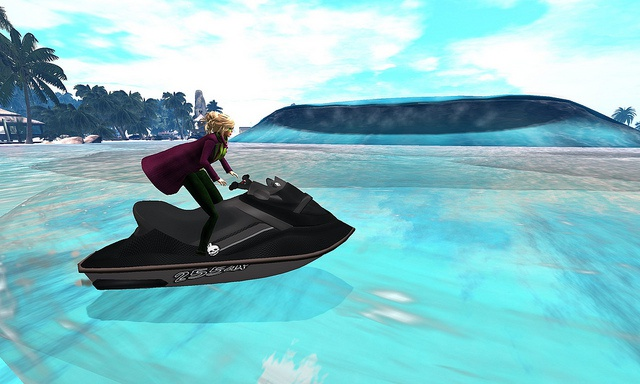Describe the objects in this image and their specific colors. I can see boat in white, black, gray, cyan, and darkgray tones and people in white, black, purple, ivory, and olive tones in this image. 